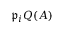<formula> <loc_0><loc_0><loc_500><loc_500>{ \mathfrak { p } } _ { i } Q ( A )</formula> 